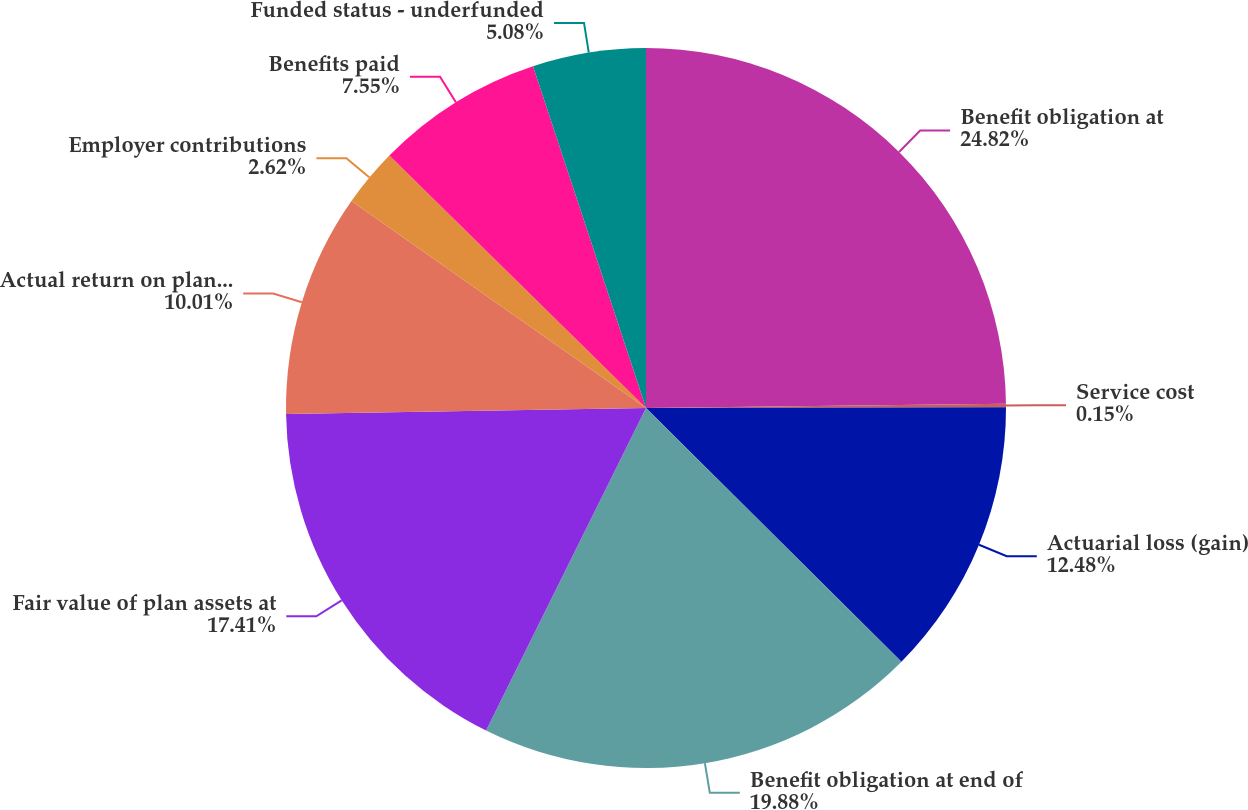Convert chart. <chart><loc_0><loc_0><loc_500><loc_500><pie_chart><fcel>Benefit obligation at<fcel>Service cost<fcel>Actuarial loss (gain)<fcel>Benefit obligation at end of<fcel>Fair value of plan assets at<fcel>Actual return on plan assets<fcel>Employer contributions<fcel>Benefits paid<fcel>Funded status - underfunded<nl><fcel>24.81%<fcel>0.15%<fcel>12.48%<fcel>19.88%<fcel>17.41%<fcel>10.01%<fcel>2.62%<fcel>7.55%<fcel>5.08%<nl></chart> 